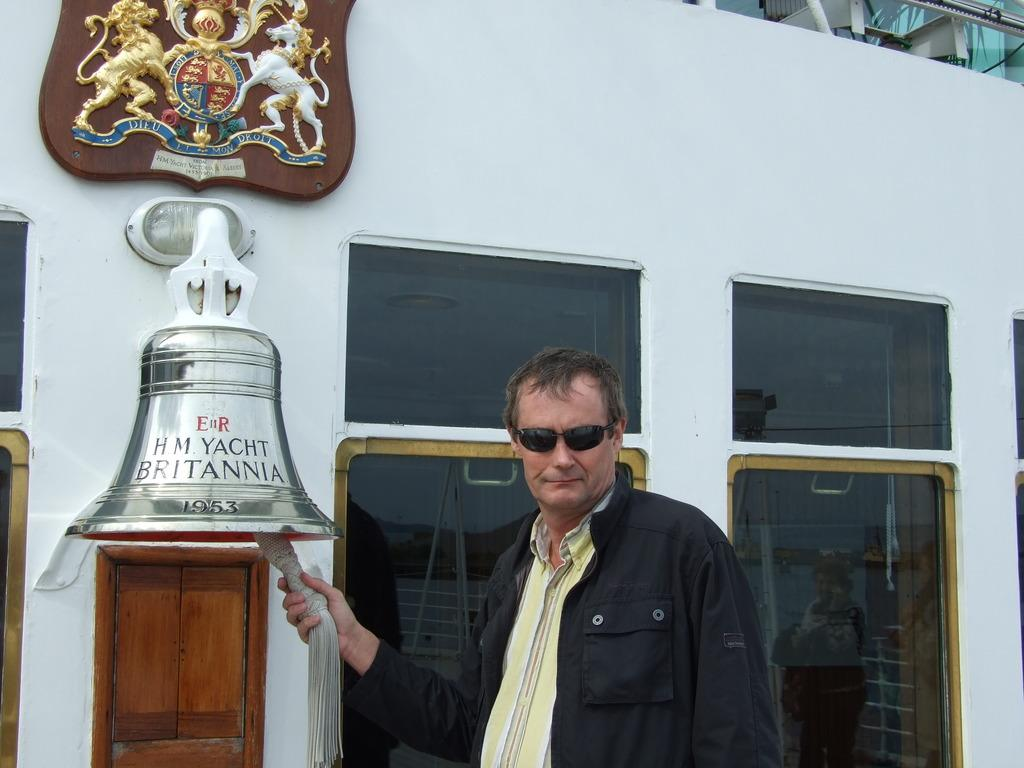What is the main subject of the image? There is a man standing in the center of the image. What is the man holding in his hand? The man is holding a bell in his hand. What can be seen in the background of the image? There is a wall and a door in the background of the image. Is there any symbol or design on the wall in the background? Yes, there is an emblem placed on the wall in the background of the image. What arithmetic problem is the actor solving in the image? There is no actor present in the image, nor is there any arithmetic problem being solved. What type of rake is being used to clean the area in the image? There is no rake present in the image; the man is holding a bell. 